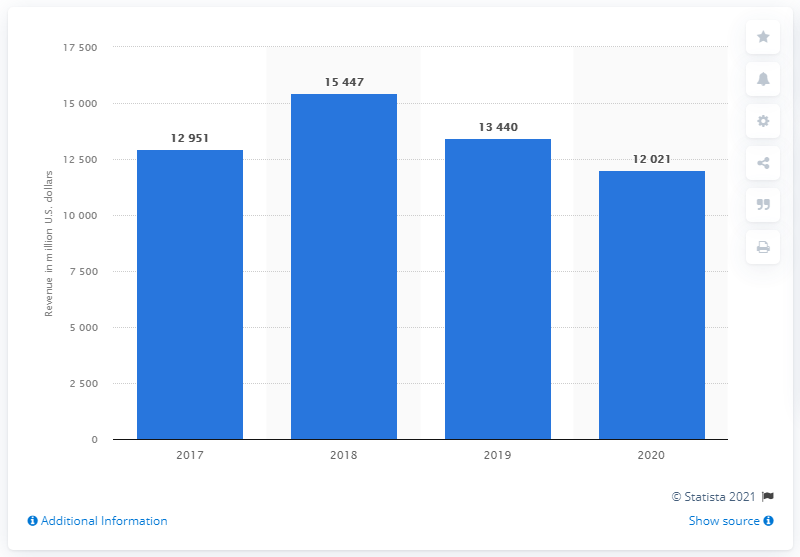Draw attention to some important aspects in this diagram. In 2020, the Industrial Intermediates & Infrastructure segment of Dow generated a revenue of 12021. 